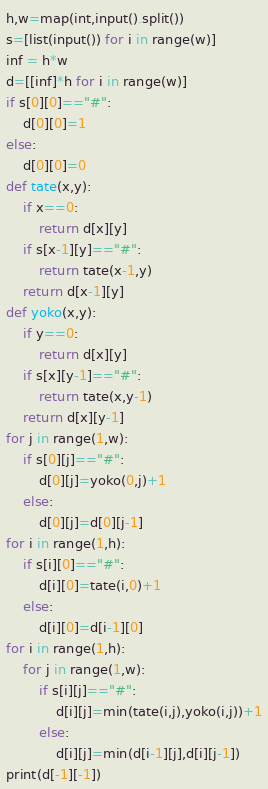<code> <loc_0><loc_0><loc_500><loc_500><_Python_>h,w=map(int,input().split())
s=[list(input()) for i in range(w)]
inf = h*w
d=[[inf]*h for i in range(w)]
if s[0][0]=="#":
    d[0][0]=1
else:
    d[0][0]=0
def tate(x,y):
    if x==0:
        return d[x][y]
    if s[x-1][y]=="#":
        return tate(x-1,y)
    return d[x-1][y]
def yoko(x,y):
    if y==0:
        return d[x][y]
    if s[x][y-1]=="#":
        return tate(x,y-1)
    return d[x][y-1]
for j in range(1,w):
    if s[0][j]=="#":
        d[0][j]=yoko(0,j)+1
    else:
        d[0][j]=d[0][j-1]
for i in range(1,h):
    if s[i][0]=="#":
        d[i][0]=tate(i,0)+1
    else:
        d[i][0]=d[i-1][0]
for i in range(1,h):
    for j in range(1,w):
        if s[i][j]=="#":
            d[i][j]=min(tate(i,j),yoko(i,j))+1
        else:
            d[i][j]=min(d[i-1][j],d[i][j-1])
print(d[-1][-1])</code> 